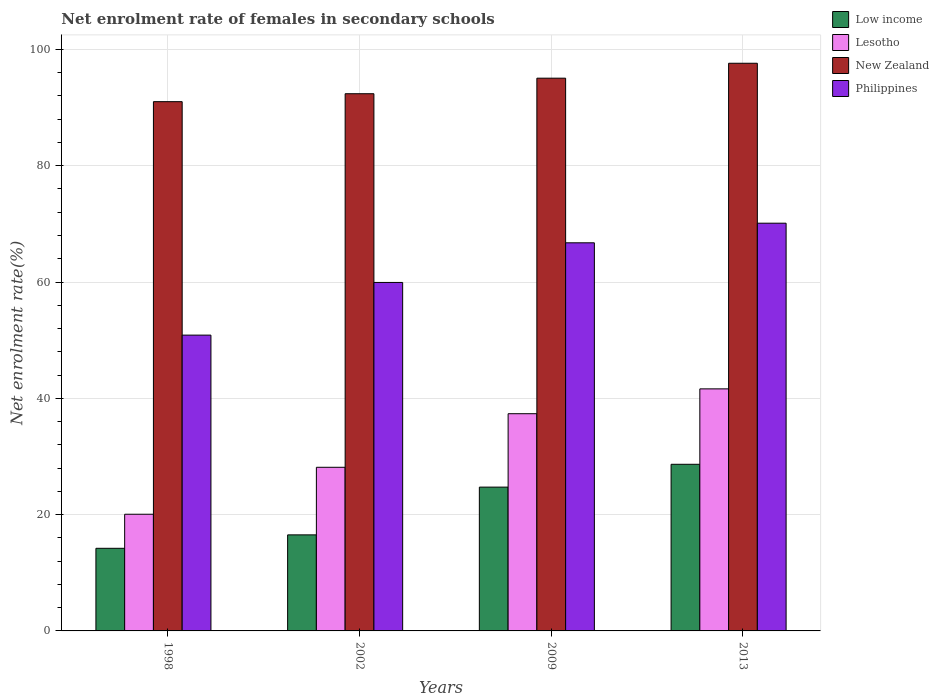How many different coloured bars are there?
Your answer should be compact. 4. Are the number of bars per tick equal to the number of legend labels?
Your answer should be very brief. Yes. How many bars are there on the 4th tick from the left?
Provide a short and direct response. 4. What is the label of the 3rd group of bars from the left?
Offer a terse response. 2009. What is the net enrolment rate of females in secondary schools in Lesotho in 1998?
Provide a short and direct response. 20.06. Across all years, what is the maximum net enrolment rate of females in secondary schools in Philippines?
Offer a very short reply. 70.11. Across all years, what is the minimum net enrolment rate of females in secondary schools in Low income?
Your answer should be very brief. 14.21. In which year was the net enrolment rate of females in secondary schools in Low income minimum?
Provide a succinct answer. 1998. What is the total net enrolment rate of females in secondary schools in Philippines in the graph?
Make the answer very short. 247.65. What is the difference between the net enrolment rate of females in secondary schools in Philippines in 2002 and that in 2009?
Offer a terse response. -6.82. What is the difference between the net enrolment rate of females in secondary schools in Philippines in 1998 and the net enrolment rate of females in secondary schools in Lesotho in 2002?
Your answer should be very brief. 22.73. What is the average net enrolment rate of females in secondary schools in Philippines per year?
Your response must be concise. 61.91. In the year 2009, what is the difference between the net enrolment rate of females in secondary schools in New Zealand and net enrolment rate of females in secondary schools in Lesotho?
Provide a short and direct response. 57.7. What is the ratio of the net enrolment rate of females in secondary schools in Lesotho in 1998 to that in 2002?
Your answer should be compact. 0.71. Is the net enrolment rate of females in secondary schools in New Zealand in 1998 less than that in 2009?
Your answer should be compact. Yes. Is the difference between the net enrolment rate of females in secondary schools in New Zealand in 1998 and 2009 greater than the difference between the net enrolment rate of females in secondary schools in Lesotho in 1998 and 2009?
Make the answer very short. Yes. What is the difference between the highest and the second highest net enrolment rate of females in secondary schools in Lesotho?
Give a very brief answer. 4.27. What is the difference between the highest and the lowest net enrolment rate of females in secondary schools in New Zealand?
Give a very brief answer. 6.61. Is the sum of the net enrolment rate of females in secondary schools in Philippines in 1998 and 2002 greater than the maximum net enrolment rate of females in secondary schools in Low income across all years?
Offer a terse response. Yes. What does the 2nd bar from the left in 2002 represents?
Your answer should be compact. Lesotho. What does the 2nd bar from the right in 2009 represents?
Your response must be concise. New Zealand. Is it the case that in every year, the sum of the net enrolment rate of females in secondary schools in Philippines and net enrolment rate of females in secondary schools in New Zealand is greater than the net enrolment rate of females in secondary schools in Low income?
Your answer should be compact. Yes. What is the difference between two consecutive major ticks on the Y-axis?
Provide a succinct answer. 20. How many legend labels are there?
Offer a terse response. 4. How are the legend labels stacked?
Offer a terse response. Vertical. What is the title of the graph?
Offer a very short reply. Net enrolment rate of females in secondary schools. Does "World" appear as one of the legend labels in the graph?
Keep it short and to the point. No. What is the label or title of the X-axis?
Your answer should be very brief. Years. What is the label or title of the Y-axis?
Ensure brevity in your answer.  Net enrolment rate(%). What is the Net enrolment rate(%) in Low income in 1998?
Keep it short and to the point. 14.21. What is the Net enrolment rate(%) in Lesotho in 1998?
Provide a short and direct response. 20.06. What is the Net enrolment rate(%) of New Zealand in 1998?
Make the answer very short. 91.01. What is the Net enrolment rate(%) in Philippines in 1998?
Keep it short and to the point. 50.87. What is the Net enrolment rate(%) of Low income in 2002?
Your response must be concise. 16.52. What is the Net enrolment rate(%) in Lesotho in 2002?
Your response must be concise. 28.14. What is the Net enrolment rate(%) in New Zealand in 2002?
Give a very brief answer. 92.38. What is the Net enrolment rate(%) of Philippines in 2002?
Offer a terse response. 59.93. What is the Net enrolment rate(%) of Low income in 2009?
Your response must be concise. 24.73. What is the Net enrolment rate(%) in Lesotho in 2009?
Your response must be concise. 37.35. What is the Net enrolment rate(%) in New Zealand in 2009?
Keep it short and to the point. 95.05. What is the Net enrolment rate(%) of Philippines in 2009?
Give a very brief answer. 66.74. What is the Net enrolment rate(%) in Low income in 2013?
Offer a very short reply. 28.66. What is the Net enrolment rate(%) of Lesotho in 2013?
Your response must be concise. 41.63. What is the Net enrolment rate(%) in New Zealand in 2013?
Offer a very short reply. 97.62. What is the Net enrolment rate(%) in Philippines in 2013?
Offer a very short reply. 70.11. Across all years, what is the maximum Net enrolment rate(%) of Low income?
Your answer should be very brief. 28.66. Across all years, what is the maximum Net enrolment rate(%) of Lesotho?
Provide a short and direct response. 41.63. Across all years, what is the maximum Net enrolment rate(%) of New Zealand?
Your answer should be compact. 97.62. Across all years, what is the maximum Net enrolment rate(%) of Philippines?
Your response must be concise. 70.11. Across all years, what is the minimum Net enrolment rate(%) in Low income?
Your answer should be compact. 14.21. Across all years, what is the minimum Net enrolment rate(%) of Lesotho?
Your answer should be compact. 20.06. Across all years, what is the minimum Net enrolment rate(%) in New Zealand?
Offer a very short reply. 91.01. Across all years, what is the minimum Net enrolment rate(%) in Philippines?
Provide a short and direct response. 50.87. What is the total Net enrolment rate(%) in Low income in the graph?
Ensure brevity in your answer.  84.11. What is the total Net enrolment rate(%) in Lesotho in the graph?
Your answer should be very brief. 127.18. What is the total Net enrolment rate(%) of New Zealand in the graph?
Offer a terse response. 376.06. What is the total Net enrolment rate(%) of Philippines in the graph?
Your response must be concise. 247.65. What is the difference between the Net enrolment rate(%) in Low income in 1998 and that in 2002?
Your answer should be very brief. -2.31. What is the difference between the Net enrolment rate(%) in Lesotho in 1998 and that in 2002?
Give a very brief answer. -8.08. What is the difference between the Net enrolment rate(%) in New Zealand in 1998 and that in 2002?
Your response must be concise. -1.37. What is the difference between the Net enrolment rate(%) of Philippines in 1998 and that in 2002?
Offer a very short reply. -9.06. What is the difference between the Net enrolment rate(%) of Low income in 1998 and that in 2009?
Give a very brief answer. -10.52. What is the difference between the Net enrolment rate(%) in Lesotho in 1998 and that in 2009?
Your response must be concise. -17.29. What is the difference between the Net enrolment rate(%) of New Zealand in 1998 and that in 2009?
Offer a terse response. -4.04. What is the difference between the Net enrolment rate(%) of Philippines in 1998 and that in 2009?
Offer a terse response. -15.87. What is the difference between the Net enrolment rate(%) of Low income in 1998 and that in 2013?
Make the answer very short. -14.45. What is the difference between the Net enrolment rate(%) in Lesotho in 1998 and that in 2013?
Offer a terse response. -21.56. What is the difference between the Net enrolment rate(%) in New Zealand in 1998 and that in 2013?
Make the answer very short. -6.61. What is the difference between the Net enrolment rate(%) of Philippines in 1998 and that in 2013?
Your response must be concise. -19.25. What is the difference between the Net enrolment rate(%) of Low income in 2002 and that in 2009?
Ensure brevity in your answer.  -8.21. What is the difference between the Net enrolment rate(%) in Lesotho in 2002 and that in 2009?
Your answer should be compact. -9.21. What is the difference between the Net enrolment rate(%) in New Zealand in 2002 and that in 2009?
Offer a very short reply. -2.67. What is the difference between the Net enrolment rate(%) in Philippines in 2002 and that in 2009?
Offer a terse response. -6.82. What is the difference between the Net enrolment rate(%) in Low income in 2002 and that in 2013?
Your answer should be very brief. -12.14. What is the difference between the Net enrolment rate(%) of Lesotho in 2002 and that in 2013?
Provide a short and direct response. -13.49. What is the difference between the Net enrolment rate(%) in New Zealand in 2002 and that in 2013?
Keep it short and to the point. -5.24. What is the difference between the Net enrolment rate(%) of Philippines in 2002 and that in 2013?
Give a very brief answer. -10.19. What is the difference between the Net enrolment rate(%) of Low income in 2009 and that in 2013?
Your answer should be very brief. -3.93. What is the difference between the Net enrolment rate(%) of Lesotho in 2009 and that in 2013?
Provide a short and direct response. -4.27. What is the difference between the Net enrolment rate(%) of New Zealand in 2009 and that in 2013?
Your response must be concise. -2.57. What is the difference between the Net enrolment rate(%) in Philippines in 2009 and that in 2013?
Offer a very short reply. -3.37. What is the difference between the Net enrolment rate(%) of Low income in 1998 and the Net enrolment rate(%) of Lesotho in 2002?
Provide a succinct answer. -13.93. What is the difference between the Net enrolment rate(%) of Low income in 1998 and the Net enrolment rate(%) of New Zealand in 2002?
Offer a very short reply. -78.17. What is the difference between the Net enrolment rate(%) in Low income in 1998 and the Net enrolment rate(%) in Philippines in 2002?
Make the answer very short. -45.72. What is the difference between the Net enrolment rate(%) in Lesotho in 1998 and the Net enrolment rate(%) in New Zealand in 2002?
Give a very brief answer. -72.31. What is the difference between the Net enrolment rate(%) of Lesotho in 1998 and the Net enrolment rate(%) of Philippines in 2002?
Your answer should be compact. -39.86. What is the difference between the Net enrolment rate(%) of New Zealand in 1998 and the Net enrolment rate(%) of Philippines in 2002?
Your answer should be very brief. 31.09. What is the difference between the Net enrolment rate(%) in Low income in 1998 and the Net enrolment rate(%) in Lesotho in 2009?
Your answer should be compact. -23.15. What is the difference between the Net enrolment rate(%) in Low income in 1998 and the Net enrolment rate(%) in New Zealand in 2009?
Provide a succinct answer. -80.85. What is the difference between the Net enrolment rate(%) in Low income in 1998 and the Net enrolment rate(%) in Philippines in 2009?
Ensure brevity in your answer.  -52.54. What is the difference between the Net enrolment rate(%) in Lesotho in 1998 and the Net enrolment rate(%) in New Zealand in 2009?
Your answer should be very brief. -74.99. What is the difference between the Net enrolment rate(%) in Lesotho in 1998 and the Net enrolment rate(%) in Philippines in 2009?
Make the answer very short. -46.68. What is the difference between the Net enrolment rate(%) of New Zealand in 1998 and the Net enrolment rate(%) of Philippines in 2009?
Your answer should be very brief. 24.27. What is the difference between the Net enrolment rate(%) of Low income in 1998 and the Net enrolment rate(%) of Lesotho in 2013?
Offer a very short reply. -27.42. What is the difference between the Net enrolment rate(%) in Low income in 1998 and the Net enrolment rate(%) in New Zealand in 2013?
Your answer should be compact. -83.41. What is the difference between the Net enrolment rate(%) in Low income in 1998 and the Net enrolment rate(%) in Philippines in 2013?
Offer a very short reply. -55.91. What is the difference between the Net enrolment rate(%) in Lesotho in 1998 and the Net enrolment rate(%) in New Zealand in 2013?
Provide a succinct answer. -77.55. What is the difference between the Net enrolment rate(%) of Lesotho in 1998 and the Net enrolment rate(%) of Philippines in 2013?
Give a very brief answer. -50.05. What is the difference between the Net enrolment rate(%) of New Zealand in 1998 and the Net enrolment rate(%) of Philippines in 2013?
Your answer should be compact. 20.9. What is the difference between the Net enrolment rate(%) of Low income in 2002 and the Net enrolment rate(%) of Lesotho in 2009?
Your answer should be compact. -20.84. What is the difference between the Net enrolment rate(%) of Low income in 2002 and the Net enrolment rate(%) of New Zealand in 2009?
Ensure brevity in your answer.  -78.54. What is the difference between the Net enrolment rate(%) of Low income in 2002 and the Net enrolment rate(%) of Philippines in 2009?
Give a very brief answer. -50.23. What is the difference between the Net enrolment rate(%) of Lesotho in 2002 and the Net enrolment rate(%) of New Zealand in 2009?
Make the answer very short. -66.91. What is the difference between the Net enrolment rate(%) in Lesotho in 2002 and the Net enrolment rate(%) in Philippines in 2009?
Your answer should be very brief. -38.6. What is the difference between the Net enrolment rate(%) in New Zealand in 2002 and the Net enrolment rate(%) in Philippines in 2009?
Ensure brevity in your answer.  25.64. What is the difference between the Net enrolment rate(%) in Low income in 2002 and the Net enrolment rate(%) in Lesotho in 2013?
Keep it short and to the point. -25.11. What is the difference between the Net enrolment rate(%) in Low income in 2002 and the Net enrolment rate(%) in New Zealand in 2013?
Offer a very short reply. -81.1. What is the difference between the Net enrolment rate(%) in Low income in 2002 and the Net enrolment rate(%) in Philippines in 2013?
Keep it short and to the point. -53.6. What is the difference between the Net enrolment rate(%) in Lesotho in 2002 and the Net enrolment rate(%) in New Zealand in 2013?
Your answer should be very brief. -69.48. What is the difference between the Net enrolment rate(%) of Lesotho in 2002 and the Net enrolment rate(%) of Philippines in 2013?
Ensure brevity in your answer.  -41.97. What is the difference between the Net enrolment rate(%) in New Zealand in 2002 and the Net enrolment rate(%) in Philippines in 2013?
Offer a terse response. 22.26. What is the difference between the Net enrolment rate(%) of Low income in 2009 and the Net enrolment rate(%) of Lesotho in 2013?
Keep it short and to the point. -16.89. What is the difference between the Net enrolment rate(%) in Low income in 2009 and the Net enrolment rate(%) in New Zealand in 2013?
Offer a very short reply. -72.89. What is the difference between the Net enrolment rate(%) of Low income in 2009 and the Net enrolment rate(%) of Philippines in 2013?
Your response must be concise. -45.38. What is the difference between the Net enrolment rate(%) of Lesotho in 2009 and the Net enrolment rate(%) of New Zealand in 2013?
Offer a very short reply. -60.27. What is the difference between the Net enrolment rate(%) of Lesotho in 2009 and the Net enrolment rate(%) of Philippines in 2013?
Ensure brevity in your answer.  -32.76. What is the difference between the Net enrolment rate(%) in New Zealand in 2009 and the Net enrolment rate(%) in Philippines in 2013?
Provide a succinct answer. 24.94. What is the average Net enrolment rate(%) of Low income per year?
Your answer should be very brief. 21.03. What is the average Net enrolment rate(%) of Lesotho per year?
Provide a short and direct response. 31.8. What is the average Net enrolment rate(%) of New Zealand per year?
Keep it short and to the point. 94.02. What is the average Net enrolment rate(%) in Philippines per year?
Keep it short and to the point. 61.91. In the year 1998, what is the difference between the Net enrolment rate(%) in Low income and Net enrolment rate(%) in Lesotho?
Offer a terse response. -5.86. In the year 1998, what is the difference between the Net enrolment rate(%) in Low income and Net enrolment rate(%) in New Zealand?
Your response must be concise. -76.81. In the year 1998, what is the difference between the Net enrolment rate(%) of Low income and Net enrolment rate(%) of Philippines?
Give a very brief answer. -36.66. In the year 1998, what is the difference between the Net enrolment rate(%) in Lesotho and Net enrolment rate(%) in New Zealand?
Ensure brevity in your answer.  -70.95. In the year 1998, what is the difference between the Net enrolment rate(%) of Lesotho and Net enrolment rate(%) of Philippines?
Your answer should be very brief. -30.8. In the year 1998, what is the difference between the Net enrolment rate(%) of New Zealand and Net enrolment rate(%) of Philippines?
Offer a very short reply. 40.14. In the year 2002, what is the difference between the Net enrolment rate(%) of Low income and Net enrolment rate(%) of Lesotho?
Provide a short and direct response. -11.62. In the year 2002, what is the difference between the Net enrolment rate(%) of Low income and Net enrolment rate(%) of New Zealand?
Make the answer very short. -75.86. In the year 2002, what is the difference between the Net enrolment rate(%) of Low income and Net enrolment rate(%) of Philippines?
Your answer should be compact. -43.41. In the year 2002, what is the difference between the Net enrolment rate(%) in Lesotho and Net enrolment rate(%) in New Zealand?
Offer a terse response. -64.24. In the year 2002, what is the difference between the Net enrolment rate(%) in Lesotho and Net enrolment rate(%) in Philippines?
Your answer should be compact. -31.79. In the year 2002, what is the difference between the Net enrolment rate(%) of New Zealand and Net enrolment rate(%) of Philippines?
Provide a short and direct response. 32.45. In the year 2009, what is the difference between the Net enrolment rate(%) in Low income and Net enrolment rate(%) in Lesotho?
Offer a very short reply. -12.62. In the year 2009, what is the difference between the Net enrolment rate(%) of Low income and Net enrolment rate(%) of New Zealand?
Offer a very short reply. -70.32. In the year 2009, what is the difference between the Net enrolment rate(%) of Low income and Net enrolment rate(%) of Philippines?
Provide a short and direct response. -42.01. In the year 2009, what is the difference between the Net enrolment rate(%) in Lesotho and Net enrolment rate(%) in New Zealand?
Your answer should be compact. -57.7. In the year 2009, what is the difference between the Net enrolment rate(%) of Lesotho and Net enrolment rate(%) of Philippines?
Provide a succinct answer. -29.39. In the year 2009, what is the difference between the Net enrolment rate(%) in New Zealand and Net enrolment rate(%) in Philippines?
Offer a very short reply. 28.31. In the year 2013, what is the difference between the Net enrolment rate(%) in Low income and Net enrolment rate(%) in Lesotho?
Provide a succinct answer. -12.97. In the year 2013, what is the difference between the Net enrolment rate(%) in Low income and Net enrolment rate(%) in New Zealand?
Your answer should be very brief. -68.96. In the year 2013, what is the difference between the Net enrolment rate(%) in Low income and Net enrolment rate(%) in Philippines?
Your answer should be compact. -41.46. In the year 2013, what is the difference between the Net enrolment rate(%) of Lesotho and Net enrolment rate(%) of New Zealand?
Offer a very short reply. -55.99. In the year 2013, what is the difference between the Net enrolment rate(%) of Lesotho and Net enrolment rate(%) of Philippines?
Provide a short and direct response. -28.49. In the year 2013, what is the difference between the Net enrolment rate(%) of New Zealand and Net enrolment rate(%) of Philippines?
Make the answer very short. 27.5. What is the ratio of the Net enrolment rate(%) in Low income in 1998 to that in 2002?
Your answer should be very brief. 0.86. What is the ratio of the Net enrolment rate(%) in Lesotho in 1998 to that in 2002?
Ensure brevity in your answer.  0.71. What is the ratio of the Net enrolment rate(%) of New Zealand in 1998 to that in 2002?
Provide a succinct answer. 0.99. What is the ratio of the Net enrolment rate(%) of Philippines in 1998 to that in 2002?
Your response must be concise. 0.85. What is the ratio of the Net enrolment rate(%) of Low income in 1998 to that in 2009?
Give a very brief answer. 0.57. What is the ratio of the Net enrolment rate(%) in Lesotho in 1998 to that in 2009?
Offer a terse response. 0.54. What is the ratio of the Net enrolment rate(%) of New Zealand in 1998 to that in 2009?
Offer a very short reply. 0.96. What is the ratio of the Net enrolment rate(%) of Philippines in 1998 to that in 2009?
Your response must be concise. 0.76. What is the ratio of the Net enrolment rate(%) in Low income in 1998 to that in 2013?
Keep it short and to the point. 0.5. What is the ratio of the Net enrolment rate(%) of Lesotho in 1998 to that in 2013?
Give a very brief answer. 0.48. What is the ratio of the Net enrolment rate(%) in New Zealand in 1998 to that in 2013?
Make the answer very short. 0.93. What is the ratio of the Net enrolment rate(%) in Philippines in 1998 to that in 2013?
Provide a succinct answer. 0.73. What is the ratio of the Net enrolment rate(%) of Low income in 2002 to that in 2009?
Your answer should be very brief. 0.67. What is the ratio of the Net enrolment rate(%) of Lesotho in 2002 to that in 2009?
Your answer should be very brief. 0.75. What is the ratio of the Net enrolment rate(%) in New Zealand in 2002 to that in 2009?
Your answer should be very brief. 0.97. What is the ratio of the Net enrolment rate(%) in Philippines in 2002 to that in 2009?
Ensure brevity in your answer.  0.9. What is the ratio of the Net enrolment rate(%) of Low income in 2002 to that in 2013?
Offer a terse response. 0.58. What is the ratio of the Net enrolment rate(%) in Lesotho in 2002 to that in 2013?
Keep it short and to the point. 0.68. What is the ratio of the Net enrolment rate(%) in New Zealand in 2002 to that in 2013?
Your answer should be compact. 0.95. What is the ratio of the Net enrolment rate(%) of Philippines in 2002 to that in 2013?
Your response must be concise. 0.85. What is the ratio of the Net enrolment rate(%) in Low income in 2009 to that in 2013?
Offer a very short reply. 0.86. What is the ratio of the Net enrolment rate(%) of Lesotho in 2009 to that in 2013?
Keep it short and to the point. 0.9. What is the ratio of the Net enrolment rate(%) of New Zealand in 2009 to that in 2013?
Your response must be concise. 0.97. What is the ratio of the Net enrolment rate(%) of Philippines in 2009 to that in 2013?
Offer a very short reply. 0.95. What is the difference between the highest and the second highest Net enrolment rate(%) in Low income?
Ensure brevity in your answer.  3.93. What is the difference between the highest and the second highest Net enrolment rate(%) in Lesotho?
Make the answer very short. 4.27. What is the difference between the highest and the second highest Net enrolment rate(%) in New Zealand?
Keep it short and to the point. 2.57. What is the difference between the highest and the second highest Net enrolment rate(%) in Philippines?
Provide a short and direct response. 3.37. What is the difference between the highest and the lowest Net enrolment rate(%) of Low income?
Give a very brief answer. 14.45. What is the difference between the highest and the lowest Net enrolment rate(%) in Lesotho?
Provide a succinct answer. 21.56. What is the difference between the highest and the lowest Net enrolment rate(%) in New Zealand?
Give a very brief answer. 6.61. What is the difference between the highest and the lowest Net enrolment rate(%) of Philippines?
Make the answer very short. 19.25. 